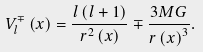Convert formula to latex. <formula><loc_0><loc_0><loc_500><loc_500>V _ { l } ^ { \mp } \left ( x \right ) = \frac { l \left ( l + 1 \right ) } { r ^ { 2 } \left ( x \right ) } \mp \frac { 3 M G } { r \left ( x \right ) ^ { 3 } } .</formula> 